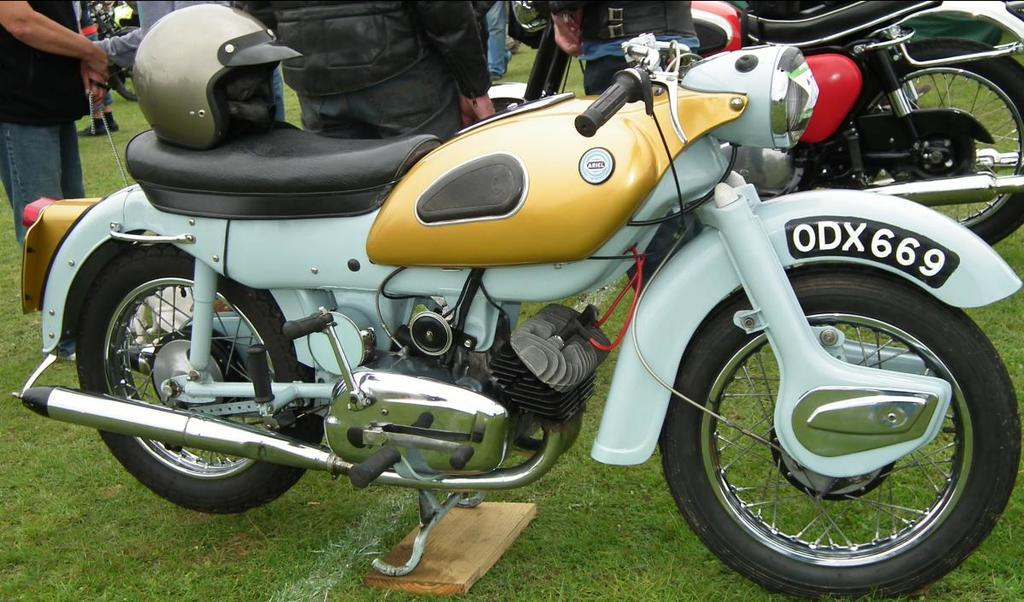What is the main subject in the center of the image? There is a bike in the center of the image. Where is the bike located? The bike is on a grassland. What safety gear is present on the grassland? There is a helmet on the grassland. What can be seen at the top side of the image? There is another bike visible at the top side of the image, along with people. What type of egg is being cooked on the bike in the image? There is no egg or cooking activity present in the image; it features a bike on a grassland. Can you see a ray swimming near the bike in the image? There is no ray or water visible in the image; it features a bike on a grassland. 